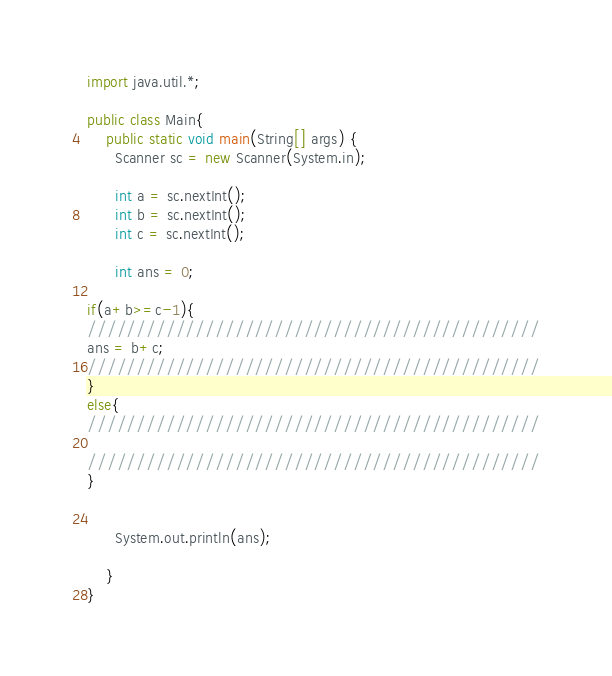<code> <loc_0><loc_0><loc_500><loc_500><_Java_>import java.util.*;

public class Main{
    public static void main(String[] args) {
      Scanner sc = new Scanner(System.in);

      int a = sc.nextInt();
      int b = sc.nextInt();
      int c = sc.nextInt();

      int ans = 0;

if(a+b>=c-1){
//////////////////////////////////////////////
ans = b+c;
//////////////////////////////////////////////
}
else{
//////////////////////////////////////////////

//////////////////////////////////////////////
}


      System.out.println(ans);

    }
}
</code> 